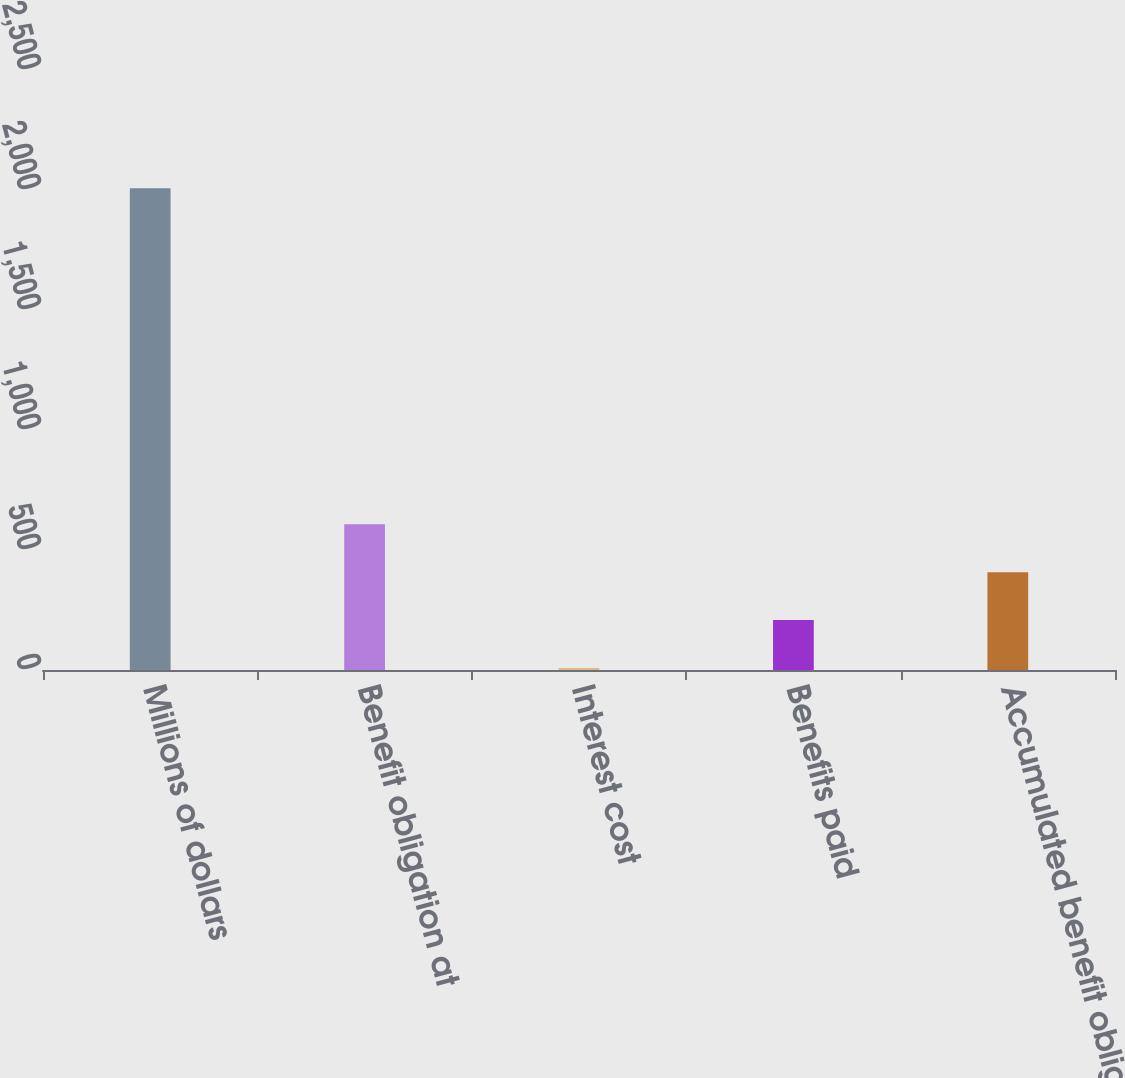<chart> <loc_0><loc_0><loc_500><loc_500><bar_chart><fcel>Millions of dollars<fcel>Benefit obligation at<fcel>Interest cost<fcel>Benefits paid<fcel>Accumulated benefit obligation<nl><fcel>2007<fcel>607.7<fcel>8<fcel>207.9<fcel>407.8<nl></chart> 